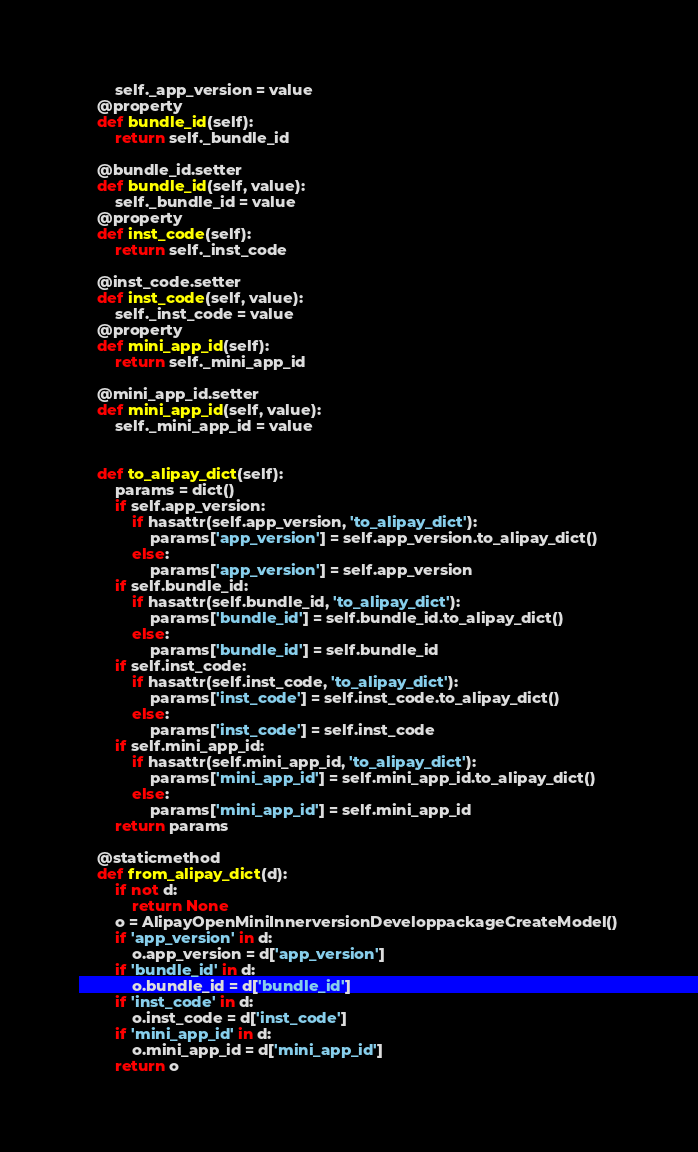Convert code to text. <code><loc_0><loc_0><loc_500><loc_500><_Python_>        self._app_version = value
    @property
    def bundle_id(self):
        return self._bundle_id

    @bundle_id.setter
    def bundle_id(self, value):
        self._bundle_id = value
    @property
    def inst_code(self):
        return self._inst_code

    @inst_code.setter
    def inst_code(self, value):
        self._inst_code = value
    @property
    def mini_app_id(self):
        return self._mini_app_id

    @mini_app_id.setter
    def mini_app_id(self, value):
        self._mini_app_id = value


    def to_alipay_dict(self):
        params = dict()
        if self.app_version:
            if hasattr(self.app_version, 'to_alipay_dict'):
                params['app_version'] = self.app_version.to_alipay_dict()
            else:
                params['app_version'] = self.app_version
        if self.bundle_id:
            if hasattr(self.bundle_id, 'to_alipay_dict'):
                params['bundle_id'] = self.bundle_id.to_alipay_dict()
            else:
                params['bundle_id'] = self.bundle_id
        if self.inst_code:
            if hasattr(self.inst_code, 'to_alipay_dict'):
                params['inst_code'] = self.inst_code.to_alipay_dict()
            else:
                params['inst_code'] = self.inst_code
        if self.mini_app_id:
            if hasattr(self.mini_app_id, 'to_alipay_dict'):
                params['mini_app_id'] = self.mini_app_id.to_alipay_dict()
            else:
                params['mini_app_id'] = self.mini_app_id
        return params

    @staticmethod
    def from_alipay_dict(d):
        if not d:
            return None
        o = AlipayOpenMiniInnerversionDeveloppackageCreateModel()
        if 'app_version' in d:
            o.app_version = d['app_version']
        if 'bundle_id' in d:
            o.bundle_id = d['bundle_id']
        if 'inst_code' in d:
            o.inst_code = d['inst_code']
        if 'mini_app_id' in d:
            o.mini_app_id = d['mini_app_id']
        return o


</code> 